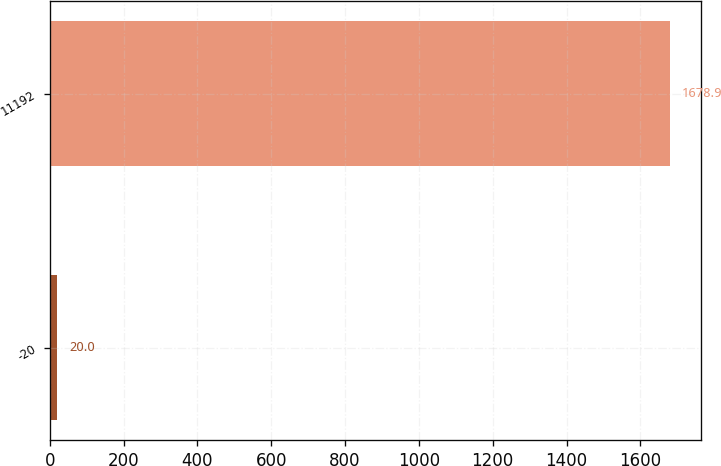<chart> <loc_0><loc_0><loc_500><loc_500><bar_chart><fcel>-20<fcel>11192<nl><fcel>20<fcel>1678.9<nl></chart> 